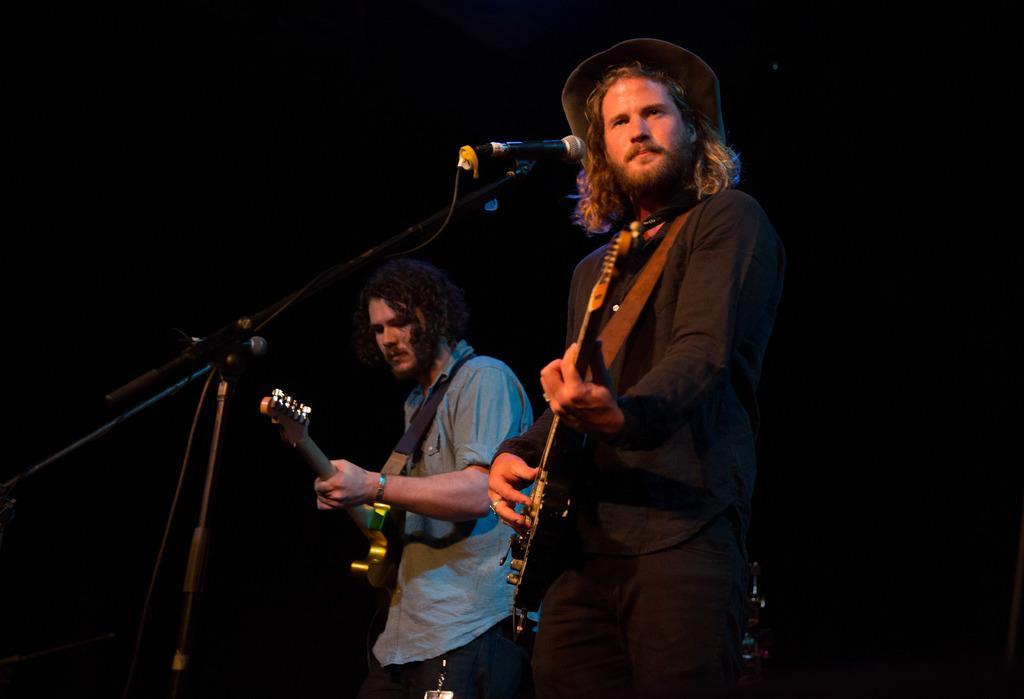How would you summarize this image in a sentence or two? In this image there are two persons who are standing. On the right side there is one person standing who is wearing black shirt and he is holding a guitar and also he is wearing a cap. In front of him there is one mike on the left side there is another man who is standing and holding a guitar in front of him there is one mike. 